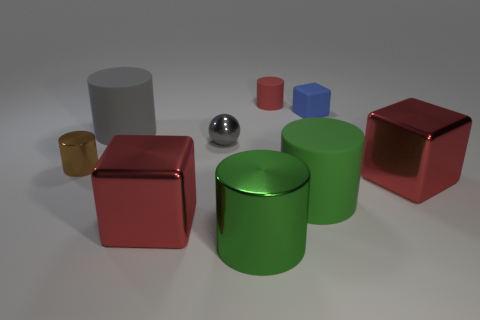How do the materials of the objects in the image influence the ambience or mood portrayed? The materials of the objects—shiny metal, matte paint, and reflective surfaces—add a sense of realism and diversity to the scene. The reflective surfaces catch light and create bright spots, giving the image a dynamic and visually rich atmosphere. 